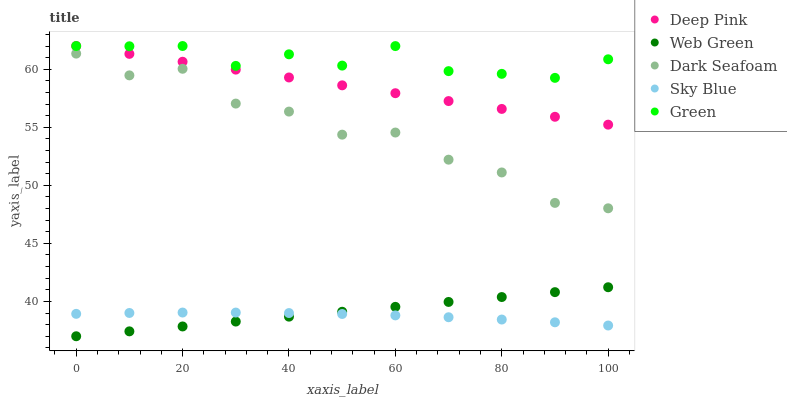Does Sky Blue have the minimum area under the curve?
Answer yes or no. Yes. Does Green have the maximum area under the curve?
Answer yes or no. Yes. Does Dark Seafoam have the minimum area under the curve?
Answer yes or no. No. Does Dark Seafoam have the maximum area under the curve?
Answer yes or no. No. Is Deep Pink the smoothest?
Answer yes or no. Yes. Is Dark Seafoam the roughest?
Answer yes or no. Yes. Is Dark Seafoam the smoothest?
Answer yes or no. No. Is Deep Pink the roughest?
Answer yes or no. No. Does Web Green have the lowest value?
Answer yes or no. Yes. Does Dark Seafoam have the lowest value?
Answer yes or no. No. Does Green have the highest value?
Answer yes or no. Yes. Does Dark Seafoam have the highest value?
Answer yes or no. No. Is Dark Seafoam less than Deep Pink?
Answer yes or no. Yes. Is Green greater than Sky Blue?
Answer yes or no. Yes. Does Sky Blue intersect Web Green?
Answer yes or no. Yes. Is Sky Blue less than Web Green?
Answer yes or no. No. Is Sky Blue greater than Web Green?
Answer yes or no. No. Does Dark Seafoam intersect Deep Pink?
Answer yes or no. No. 